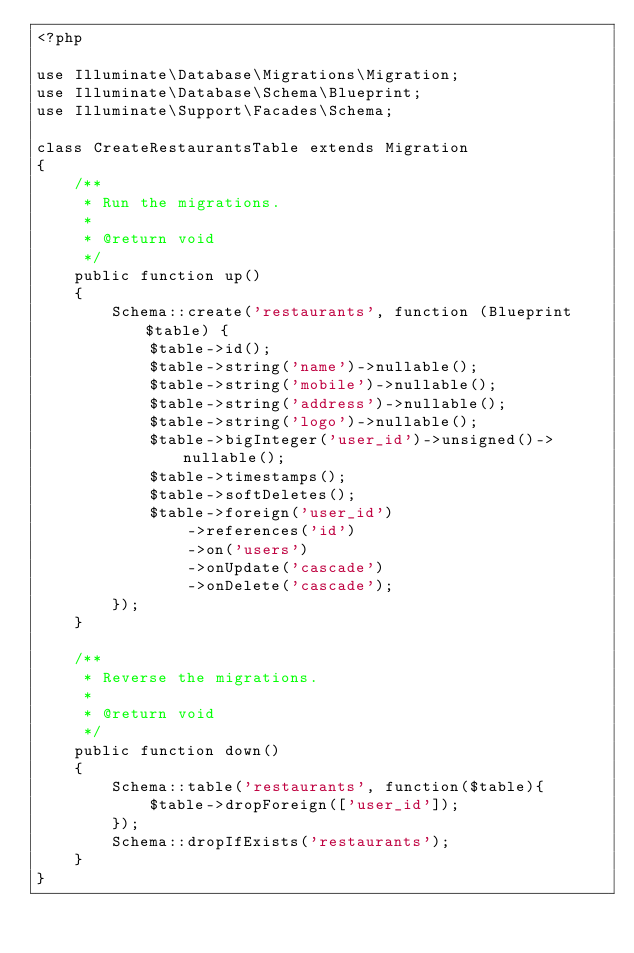<code> <loc_0><loc_0><loc_500><loc_500><_PHP_><?php

use Illuminate\Database\Migrations\Migration;
use Illuminate\Database\Schema\Blueprint;
use Illuminate\Support\Facades\Schema;

class CreateRestaurantsTable extends Migration
{
    /**
     * Run the migrations.
     *
     * @return void
     */
    public function up()
    {
        Schema::create('restaurants', function (Blueprint $table) {
            $table->id();
            $table->string('name')->nullable();
            $table->string('mobile')->nullable();
            $table->string('address')->nullable();
            $table->string('logo')->nullable();
            $table->bigInteger('user_id')->unsigned()->nullable();
            $table->timestamps();
            $table->softDeletes();
            $table->foreign('user_id')
                ->references('id')
                ->on('users')
                ->onUpdate('cascade')
                ->onDelete('cascade');
        });
    }

    /**
     * Reverse the migrations.
     *
     * @return void
     */
    public function down()
    {
        Schema::table('restaurants', function($table){
            $table->dropForeign(['user_id']);
        });
        Schema::dropIfExists('restaurants');
    }
}
</code> 